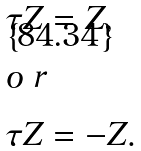Convert formula to latex. <formula><loc_0><loc_0><loc_500><loc_500>\tau Z & = Z , \\ \intertext { o r } \tau Z & = - Z .</formula> 